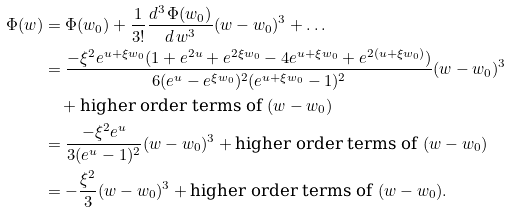Convert formula to latex. <formula><loc_0><loc_0><loc_500><loc_500>\Phi ( w ) & = \Phi ( w _ { 0 } ) + \frac { 1 } { 3 ! } \frac { d ^ { 3 } \, \Phi ( w _ { 0 } ) } { d \, w ^ { 3 } } ( w - w _ { 0 } ) ^ { 3 } + \dots \\ & = \frac { - \xi ^ { 2 } e ^ { u + \xi w _ { 0 } } ( 1 + e ^ { 2 u } + e ^ { 2 \xi w _ { 0 } } - 4 e ^ { u + \xi w _ { 0 } } + e ^ { 2 ( u + \xi w _ { 0 } ) } ) } { 6 ( e ^ { u } - e ^ { \xi w _ { 0 } } ) ^ { 2 } ( e ^ { u + \xi w _ { 0 } } - 1 ) ^ { 2 } } ( w - w _ { 0 } ) ^ { 3 } \\ & \quad + \text {higher order terms of $(w-w_{0})$} \\ & = \frac { - \xi ^ { 2 } e ^ { u } } { 3 ( e ^ { u } - 1 ) ^ { 2 } } ( w - w _ { 0 } ) ^ { 3 } + \text {higher order terms of $(w-w_{0})$} \\ & = - \frac { \xi ^ { 2 } } { 3 } ( w - w _ { 0 } ) ^ { 3 } + \text {higher order terms of $(w-w_{0})$} .</formula> 